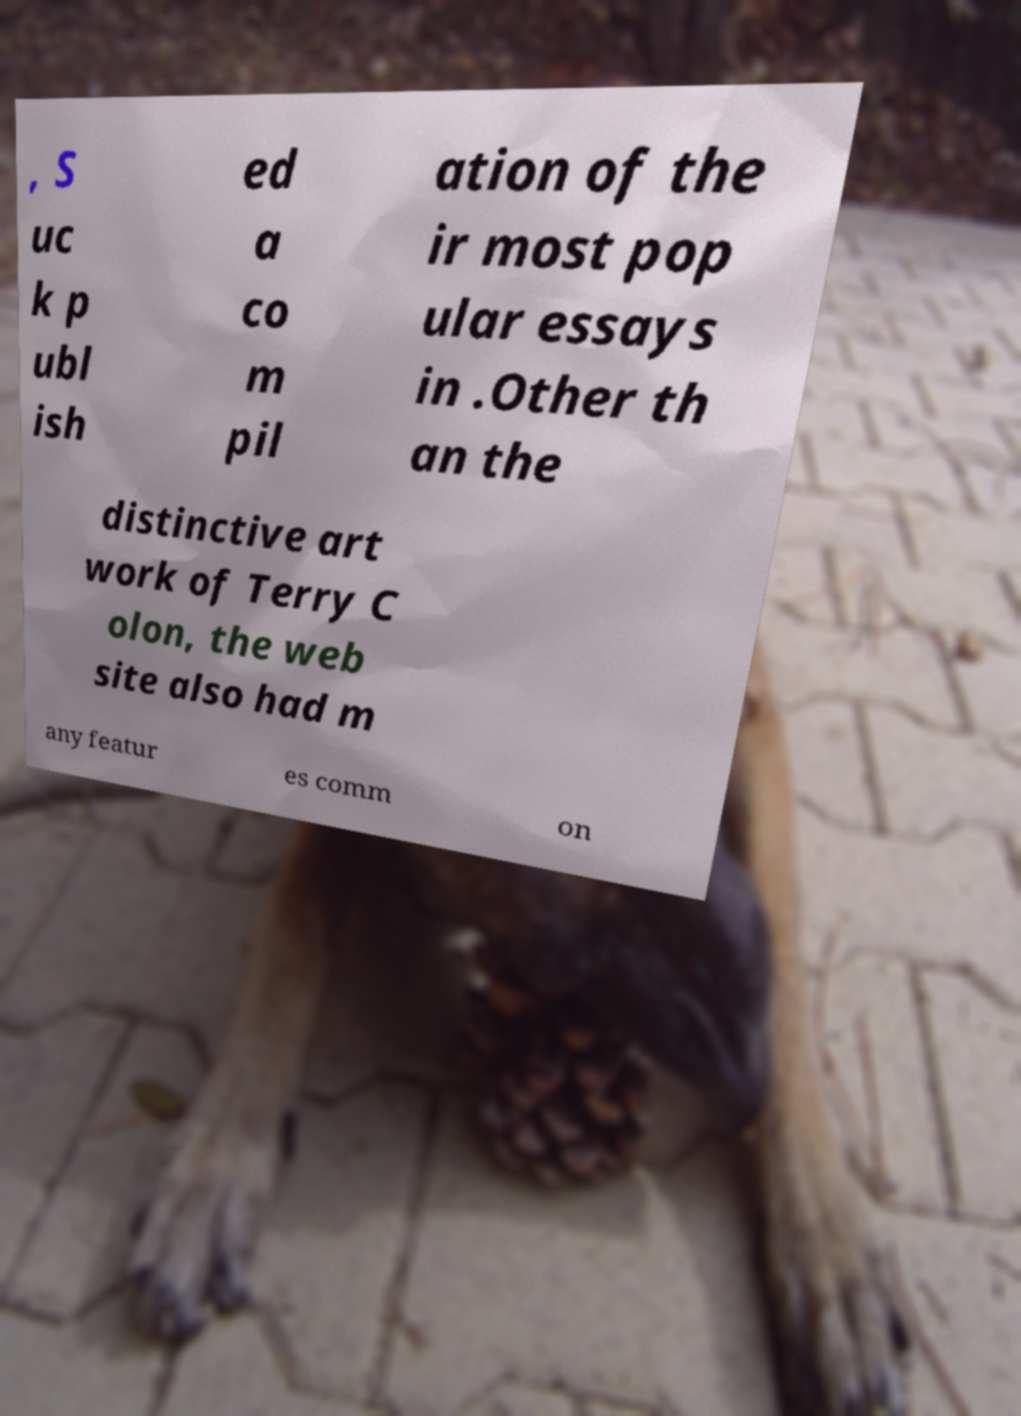Could you assist in decoding the text presented in this image and type it out clearly? , S uc k p ubl ish ed a co m pil ation of the ir most pop ular essays in .Other th an the distinctive art work of Terry C olon, the web site also had m any featur es comm on 